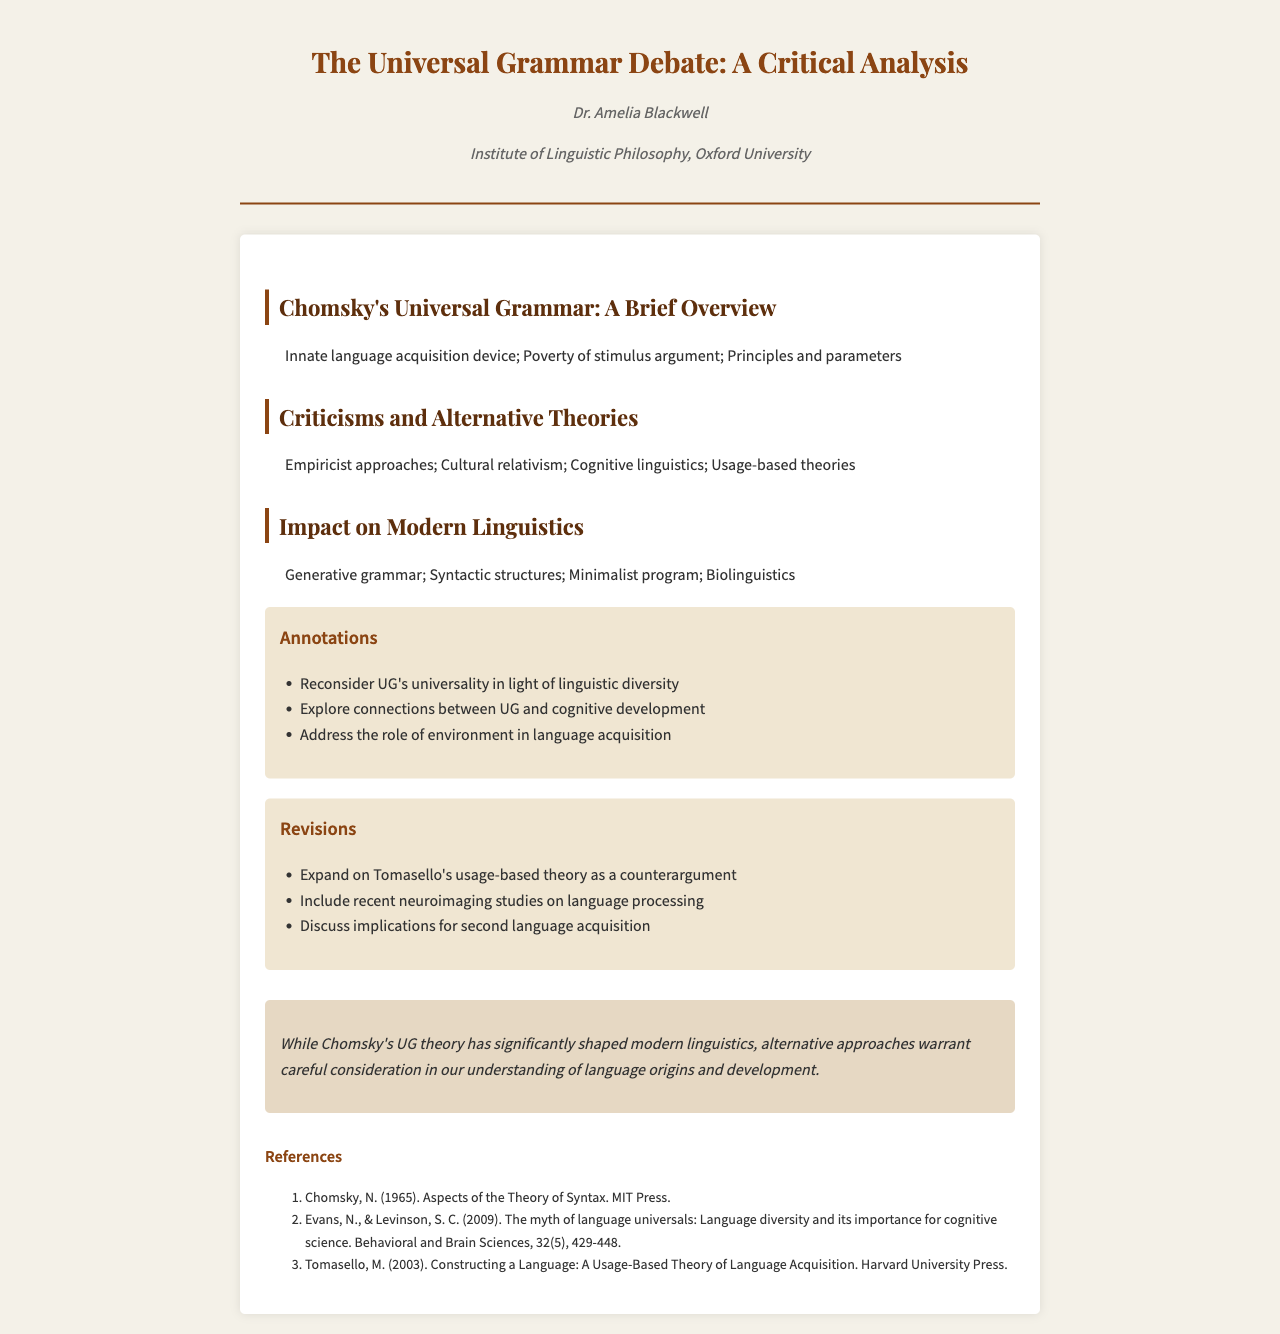What is the title of the document? The title is the main heading presented at the top of the document.
Answer: The Universal Grammar Debate: A Critical Analysis Who is the author of the manuscript? The author is identified in the fax header of the document.
Answer: Dr. Amelia Blackwell What institution is associated with the author? The institution is also mentioned in the fax header, related to the author's affiliation.
Answer: Institute of Linguistic Philosophy, Oxford University What is one criticism mentioned regarding Chomsky's theory? The criticisms section lists various alternative theories that challenge Chomsky's perspective.
Answer: Empiricist approaches Name one alternative theory to Chomsky's Universal Grammar. This information can be found in the summary of the criticisms section.
Answer: Cultural relativism What approach does the document suggest exploring in relation to Cognitive Development? Annotations highlight areas for further exploration related to Cognitive Development.
Answer: Connections between UG and cognitive development What is the main focus of the conclusion? The conclusion summarizes the overall perspective on the discussed theories in relation to Chomsky's impact.
Answer: Alternative approaches warrant careful consideration How many references are provided in the document? The number of references is listed at the end of the document.
Answer: Three What type of document is this? The structure and headers indicate that this is a formal communication primarily for academic purposes.
Answer: Fax 